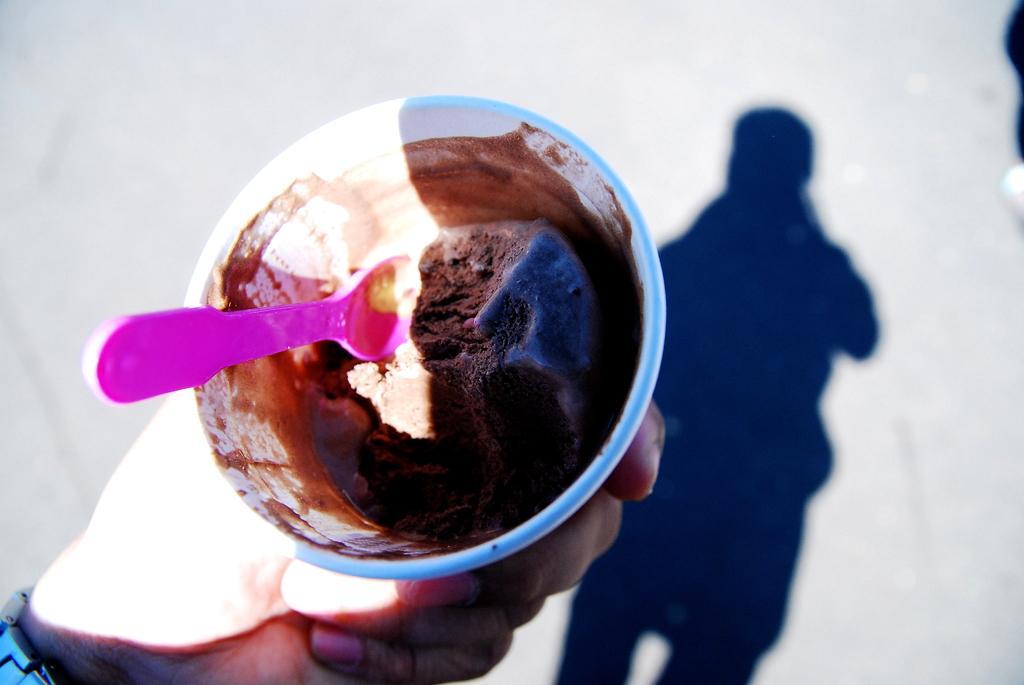Can you describe this image briefly? In this picture there is an ice cream cup in one hand and there is a shadow of one person on the floor and there is a small spoon in an ice cream cup. 